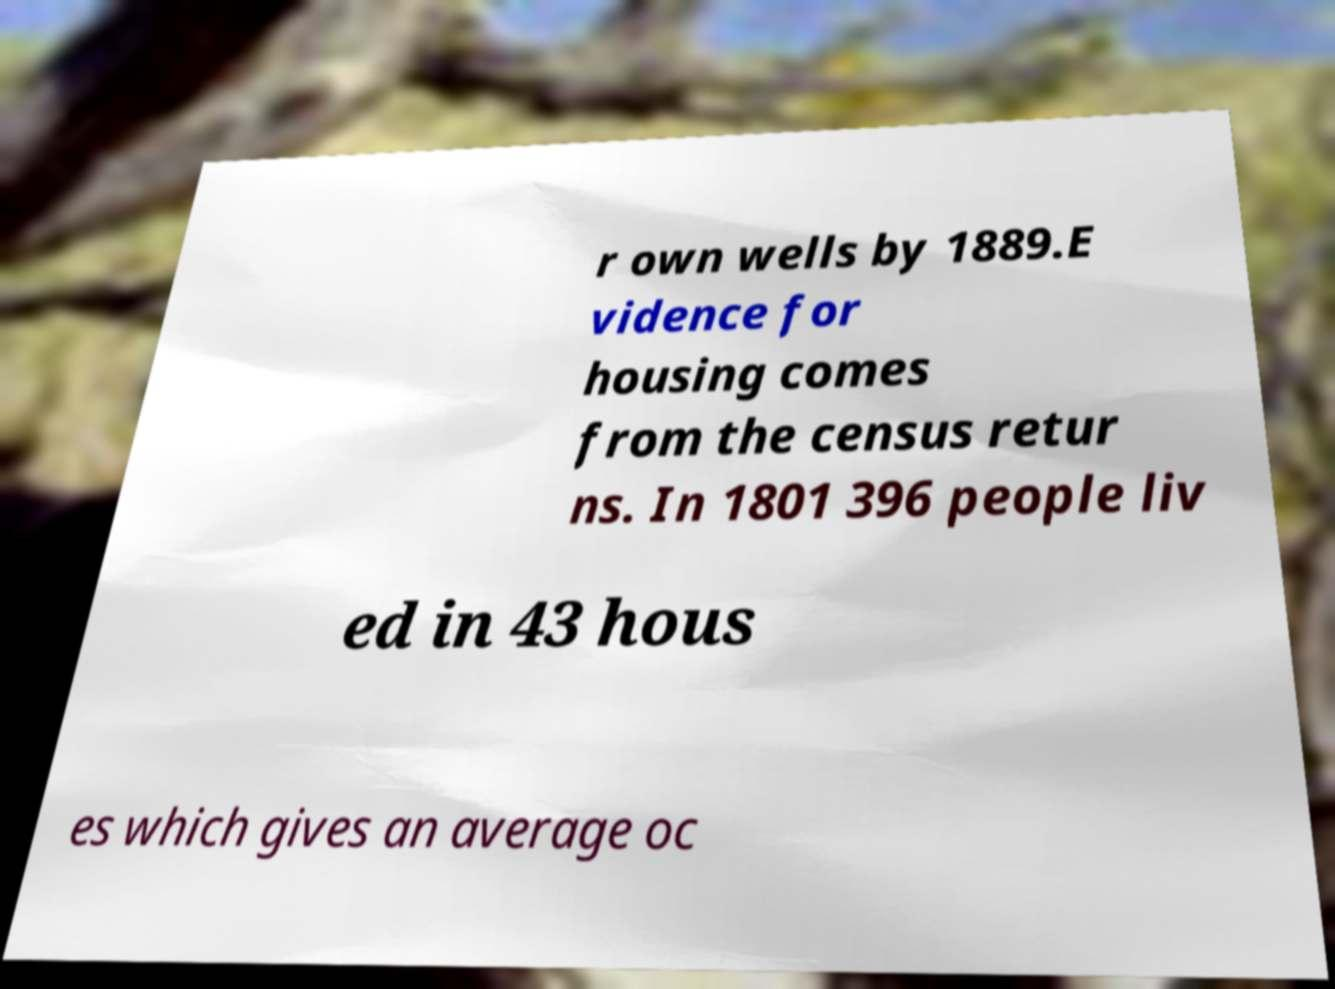Can you read and provide the text displayed in the image?This photo seems to have some interesting text. Can you extract and type it out for me? r own wells by 1889.E vidence for housing comes from the census retur ns. In 1801 396 people liv ed in 43 hous es which gives an average oc 